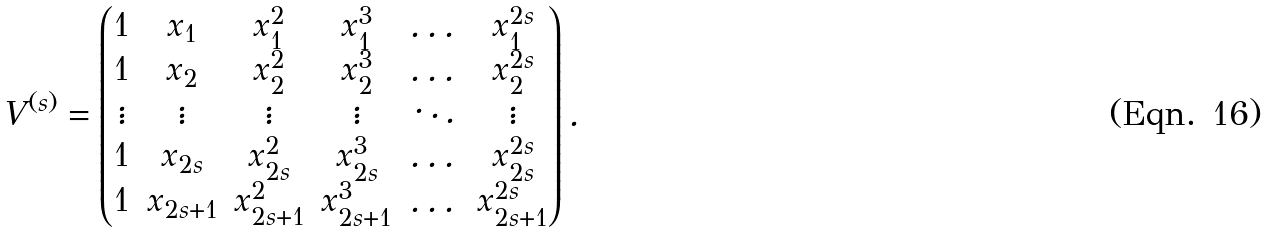Convert formula to latex. <formula><loc_0><loc_0><loc_500><loc_500>V ^ { ( s ) } = \begin{pmatrix} 1 & x _ { 1 } & x _ { 1 } ^ { 2 } & x _ { 1 } ^ { 3 } & \dots & x _ { 1 } ^ { 2 s } \\ 1 & x _ { 2 } & x _ { 2 } ^ { 2 } & x _ { 2 } ^ { 3 } & \dots & x _ { 2 } ^ { 2 s } \\ \vdots & \vdots & \vdots & \vdots & \ddots & \vdots \\ 1 & x _ { 2 s } & x _ { 2 s } ^ { 2 } & x _ { 2 s } ^ { 3 } & \dots & x _ { 2 s } ^ { 2 s } \\ 1 & x _ { 2 s + 1 } & x _ { 2 s + 1 } ^ { 2 } & x _ { 2 s + 1 } ^ { 3 } & \dots & x _ { 2 s + 1 } ^ { 2 s } \end{pmatrix} .</formula> 